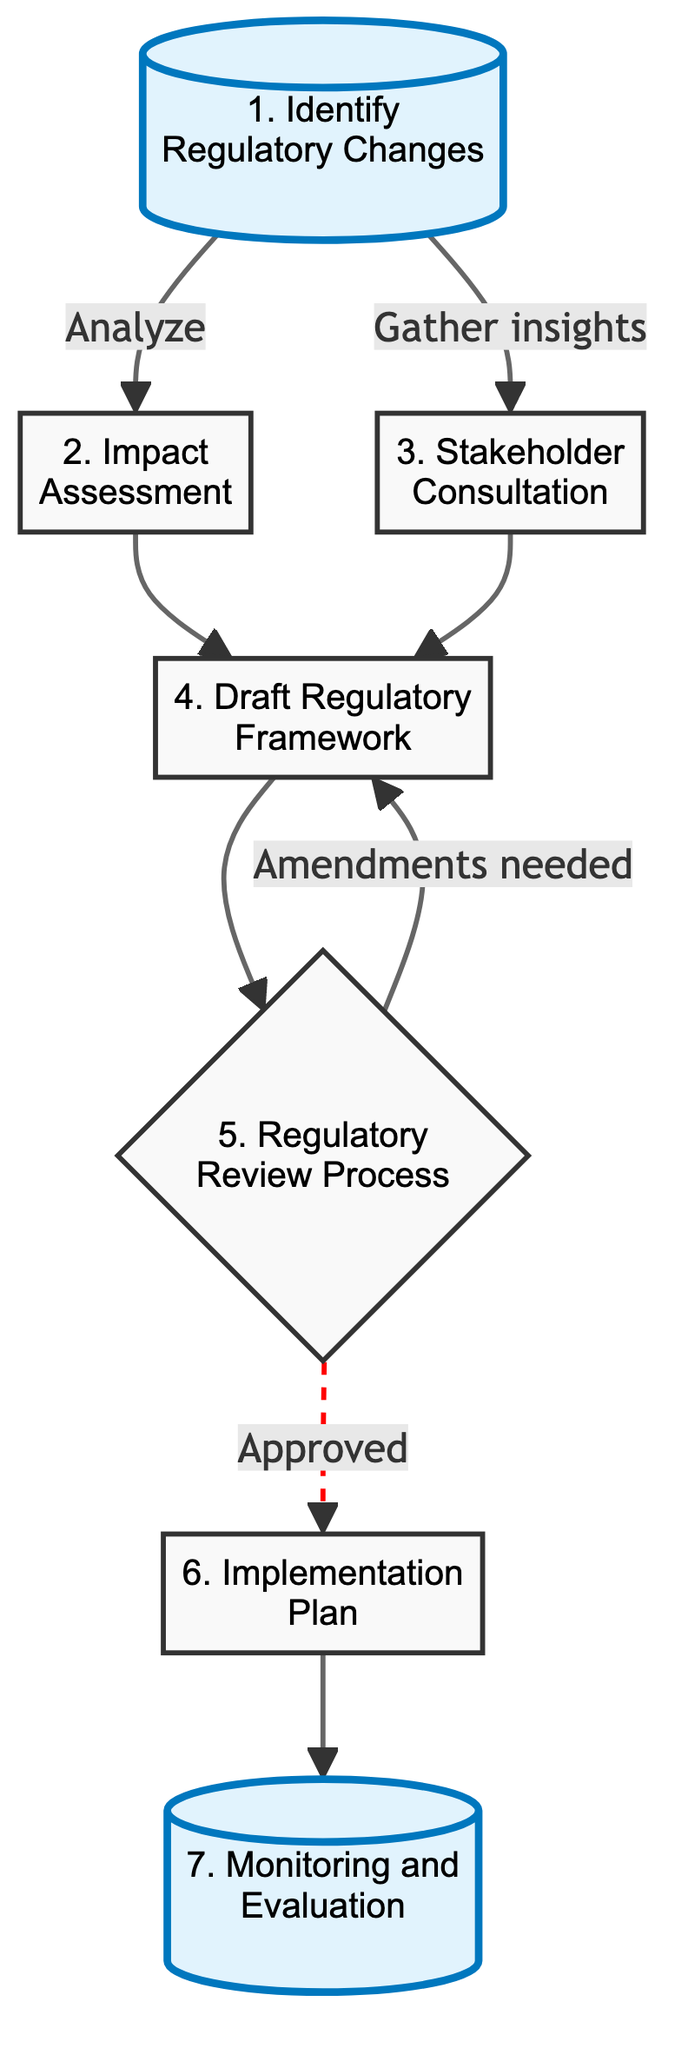What is the first step in the flow chart? The first step is labeled as "1. Identify Regulatory Changes," which initiates the process of analyzing proposed amendments to existing securities laws.
Answer: Identify Regulatory Changes How many nodes are in this flow chart? By counting the labeled processes in the chart, there are a total of 7 nodes representing different steps in the analysis of regulatory changes.
Answer: 7 What are the two possible outcomes from the Regulatory Review Process? The Regulatory Review Process can lead to two outcomes: "Approved" or "Amendments needed." This shows that the submission can either pass or require further modifications.
Answer: Approved and Amendments needed Which two steps feed into the Draft Regulatory Framework? The "Impact Assessment" and "Stakeholder Consultation" steps feed into the Draft Regulatory Framework, indicating that both analyses are essential for drafting regulations.
Answer: Impact Assessment and Stakeholder Consultation What is established after the Implementation Plan? After the Implementation Plan, the next step established in the flow chart is "Monitoring and Evaluation," indicating that tracking is necessary post-implementation.
Answer: Monitoring and Evaluation How does one progress from the Draft Regulatory Framework to the Regulatory Review Process? One progresses from the Draft Regulatory Framework to the Regulatory Review Process through a direct arrow in the flow chart, indicating a sequential step in the regulatory changes analysis.
Answer: Direct arrow What is the main focus of the Impact Assessment step? The main focus of the Impact Assessment step is to evaluate the potential impact of regulatory changes on shareholder value and market behavior.
Answer: Evaluate potential impact How are stakeholders engaged in this analysis? Stakeholders are engaged through the "Stakeholder Consultation" step, where insights and concerns are gathered from various key players in the industry.
Answer: Stakeholder Consultation 